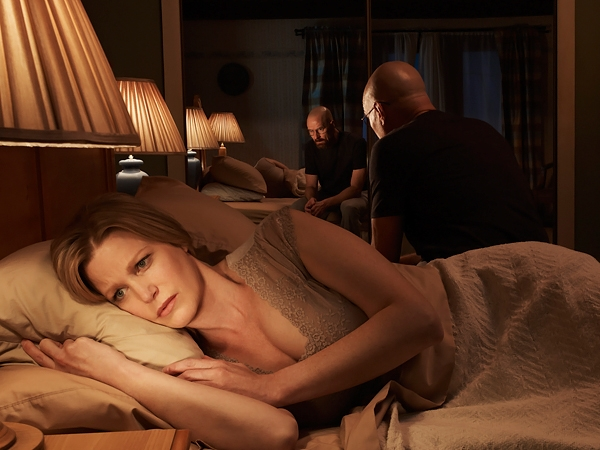What are the key elements in this picture? The picture captures a tense and contemplative scene in a bedroom setting. A woman, appearing worried and thoughtful, lies on a bed dressed in a beige nightgown. Her eyes are wide open, and her gaze seems fixed on a distant thought. The muted lighting casts soft shadows across the room, which is furnished with traditional decor including lamps, a nightstand, and heavy curtains that suggest a quiet, private space. In the background, two men engage in a conversation; one is seated on the bed, showing a contemplative expression, while the other stands by the window, partially obscured by shadows, contributing to the scene's overall sense of intrigue and emotional complexity. 